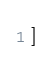Convert code to text. <code><loc_0><loc_0><loc_500><loc_500><_Python_>]
</code> 